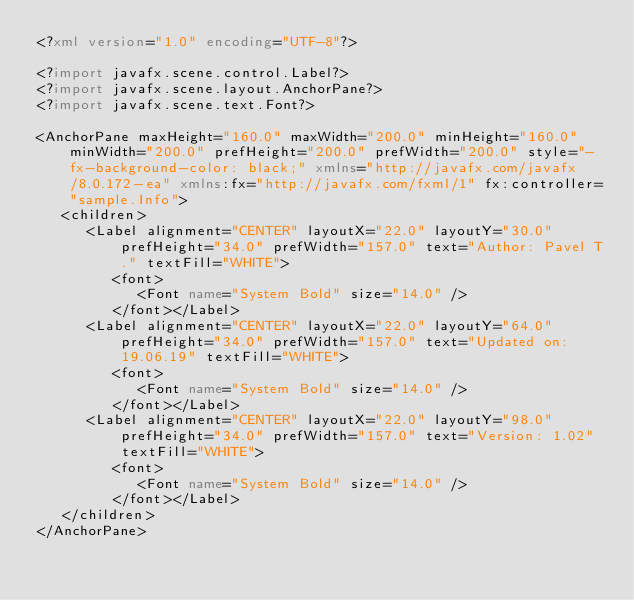Convert code to text. <code><loc_0><loc_0><loc_500><loc_500><_XML_><?xml version="1.0" encoding="UTF-8"?>

<?import javafx.scene.control.Label?>
<?import javafx.scene.layout.AnchorPane?>
<?import javafx.scene.text.Font?>

<AnchorPane maxHeight="160.0" maxWidth="200.0" minHeight="160.0" minWidth="200.0" prefHeight="200.0" prefWidth="200.0" style="-fx-background-color: black;" xmlns="http://javafx.com/javafx/8.0.172-ea" xmlns:fx="http://javafx.com/fxml/1" fx:controller="sample.Info">
   <children>
      <Label alignment="CENTER" layoutX="22.0" layoutY="30.0" prefHeight="34.0" prefWidth="157.0" text="Author: Pavel T." textFill="WHITE">
         <font>
            <Font name="System Bold" size="14.0" />
         </font></Label>
      <Label alignment="CENTER" layoutX="22.0" layoutY="64.0" prefHeight="34.0" prefWidth="157.0" text="Updated on: 19.06.19" textFill="WHITE">
         <font>
            <Font name="System Bold" size="14.0" />
         </font></Label>
      <Label alignment="CENTER" layoutX="22.0" layoutY="98.0" prefHeight="34.0" prefWidth="157.0" text="Version: 1.02" textFill="WHITE">
         <font>
            <Font name="System Bold" size="14.0" />
         </font></Label>
   </children>
</AnchorPane>
</code> 